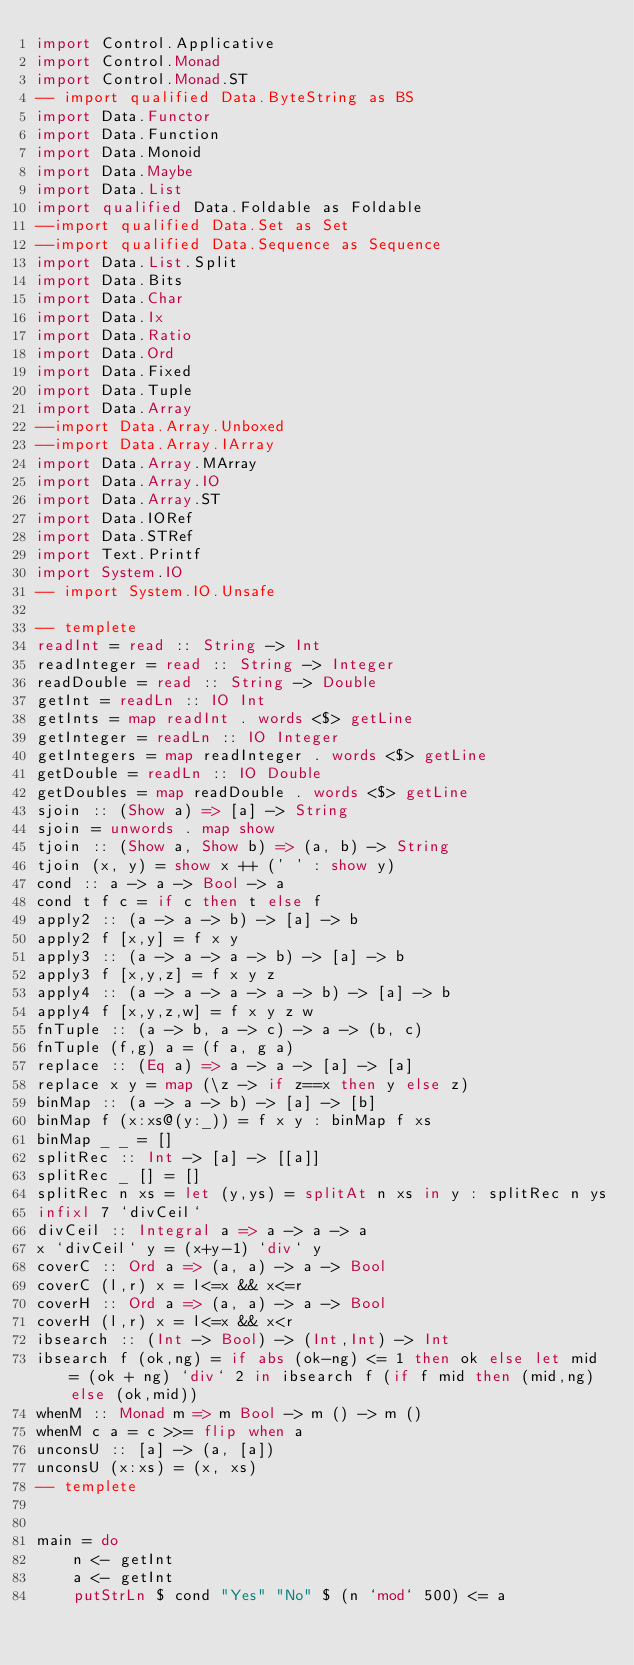Convert code to text. <code><loc_0><loc_0><loc_500><loc_500><_Haskell_>import Control.Applicative
import Control.Monad
import Control.Monad.ST
-- import qualified Data.ByteString as BS
import Data.Functor
import Data.Function
import Data.Monoid
import Data.Maybe
import Data.List
import qualified Data.Foldable as Foldable
--import qualified Data.Set as Set
--import qualified Data.Sequence as Sequence
import Data.List.Split
import Data.Bits
import Data.Char
import Data.Ix
import Data.Ratio
import Data.Ord
import Data.Fixed
import Data.Tuple
import Data.Array
--import Data.Array.Unboxed
--import Data.Array.IArray
import Data.Array.MArray
import Data.Array.IO
import Data.Array.ST
import Data.IORef
import Data.STRef
import Text.Printf
import System.IO
-- import System.IO.Unsafe
 
-- templete
readInt = read :: String -> Int
readInteger = read :: String -> Integer
readDouble = read :: String -> Double
getInt = readLn :: IO Int
getInts = map readInt . words <$> getLine
getInteger = readLn :: IO Integer
getIntegers = map readInteger . words <$> getLine
getDouble = readLn :: IO Double
getDoubles = map readDouble . words <$> getLine
sjoin :: (Show a) => [a] -> String
sjoin = unwords . map show
tjoin :: (Show a, Show b) => (a, b) -> String
tjoin (x, y) = show x ++ (' ' : show y)
cond :: a -> a -> Bool -> a
cond t f c = if c then t else f
apply2 :: (a -> a -> b) -> [a] -> b
apply2 f [x,y] = f x y
apply3 :: (a -> a -> a -> b) -> [a] -> b
apply3 f [x,y,z] = f x y z
apply4 :: (a -> a -> a -> a -> b) -> [a] -> b
apply4 f [x,y,z,w] = f x y z w
fnTuple :: (a -> b, a -> c) -> a -> (b, c)
fnTuple (f,g) a = (f a, g a)
replace :: (Eq a) => a -> a -> [a] -> [a]
replace x y = map (\z -> if z==x then y else z)
binMap :: (a -> a -> b) -> [a] -> [b]
binMap f (x:xs@(y:_)) = f x y : binMap f xs
binMap _ _ = []
splitRec :: Int -> [a] -> [[a]]
splitRec _ [] = []
splitRec n xs = let (y,ys) = splitAt n xs in y : splitRec n ys
infixl 7 `divCeil`
divCeil :: Integral a => a -> a -> a
x `divCeil` y = (x+y-1) `div` y
coverC :: Ord a => (a, a) -> a -> Bool
coverC (l,r) x = l<=x && x<=r
coverH :: Ord a => (a, a) -> a -> Bool
coverH (l,r) x = l<=x && x<r
ibsearch :: (Int -> Bool) -> (Int,Int) -> Int
ibsearch f (ok,ng) = if abs (ok-ng) <= 1 then ok else let mid = (ok + ng) `div` 2 in ibsearch f (if f mid then (mid,ng) else (ok,mid))
whenM :: Monad m => m Bool -> m () -> m ()
whenM c a = c >>= flip when a
unconsU :: [a] -> (a, [a])
unconsU (x:xs) = (x, xs)
-- templete


main = do
    n <- getInt
    a <- getInt
    putStrLn $ cond "Yes" "No" $ (n `mod` 500) <= a</code> 